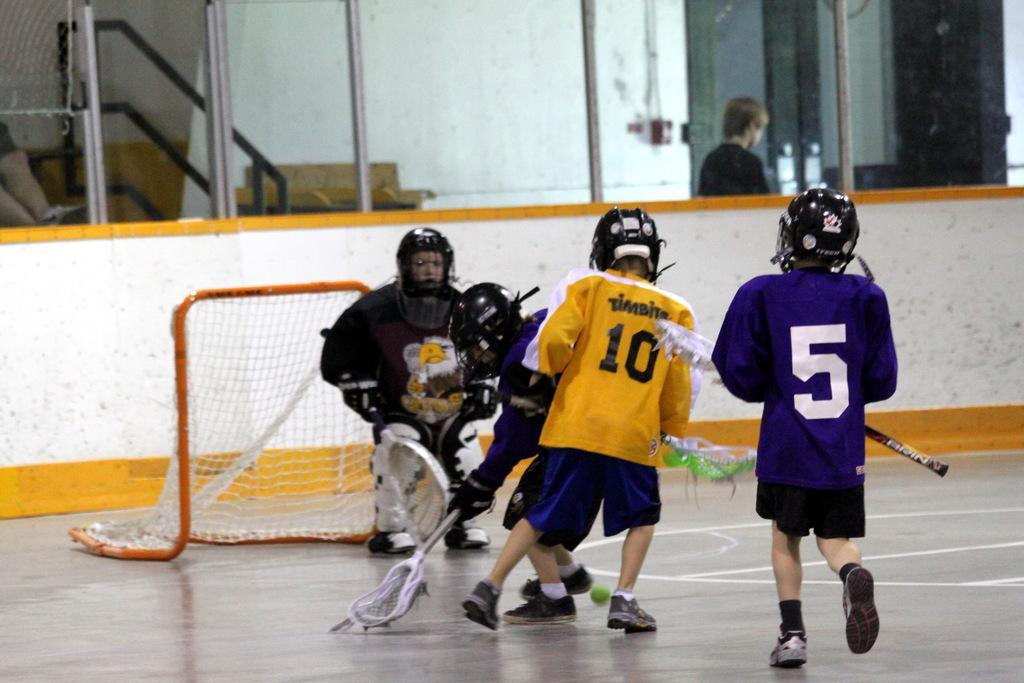Please provide a concise description of this image. In this image we can see these children wearing helmets and shoes are holding bats in their hands and standing on the ground. In the background, we can see the net, the wall and the glass windows through which we can see stairs and a person walking here. 